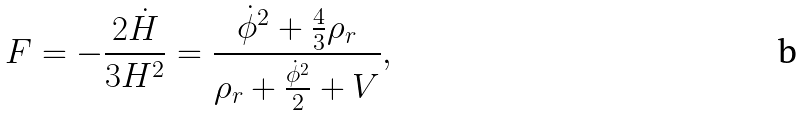Convert formula to latex. <formula><loc_0><loc_0><loc_500><loc_500>F = - \frac { 2 \dot { H } } { 3 H ^ { 2 } } = \frac { \dot { \phi } ^ { 2 } + \frac { 4 } { 3 } \rho _ { r } } { \rho _ { r } + \frac { \dot { \phi } ^ { 2 } } { 2 } + V } ,</formula> 